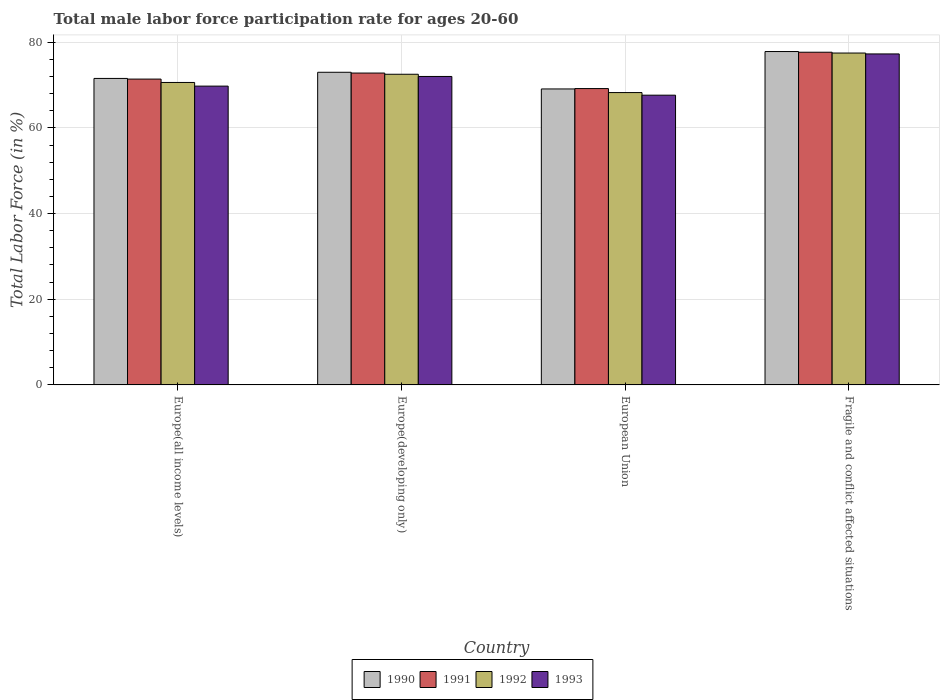How many different coloured bars are there?
Your answer should be compact. 4. Are the number of bars on each tick of the X-axis equal?
Your response must be concise. Yes. How many bars are there on the 2nd tick from the left?
Offer a very short reply. 4. What is the label of the 2nd group of bars from the left?
Provide a succinct answer. Europe(developing only). In how many cases, is the number of bars for a given country not equal to the number of legend labels?
Keep it short and to the point. 0. What is the male labor force participation rate in 1993 in Fragile and conflict affected situations?
Ensure brevity in your answer.  77.28. Across all countries, what is the maximum male labor force participation rate in 1991?
Your answer should be very brief. 77.68. Across all countries, what is the minimum male labor force participation rate in 1992?
Offer a very short reply. 68.26. In which country was the male labor force participation rate in 1990 maximum?
Your answer should be very brief. Fragile and conflict affected situations. In which country was the male labor force participation rate in 1991 minimum?
Make the answer very short. European Union. What is the total male labor force participation rate in 1990 in the graph?
Ensure brevity in your answer.  291.5. What is the difference between the male labor force participation rate in 1992 in Europe(developing only) and that in European Union?
Your answer should be compact. 4.28. What is the difference between the male labor force participation rate in 1991 in European Union and the male labor force participation rate in 1992 in Europe(all income levels)?
Give a very brief answer. -1.43. What is the average male labor force participation rate in 1991 per country?
Offer a terse response. 72.77. What is the difference between the male labor force participation rate of/in 1991 and male labor force participation rate of/in 1993 in Fragile and conflict affected situations?
Provide a succinct answer. 0.4. What is the ratio of the male labor force participation rate in 1990 in Europe(all income levels) to that in European Union?
Ensure brevity in your answer.  1.04. Is the male labor force participation rate in 1992 in Europe(all income levels) less than that in Fragile and conflict affected situations?
Make the answer very short. Yes. Is the difference between the male labor force participation rate in 1991 in Europe(developing only) and European Union greater than the difference between the male labor force participation rate in 1993 in Europe(developing only) and European Union?
Your answer should be very brief. No. What is the difference between the highest and the second highest male labor force participation rate in 1991?
Offer a very short reply. -4.86. What is the difference between the highest and the lowest male labor force participation rate in 1993?
Offer a terse response. 9.63. In how many countries, is the male labor force participation rate in 1990 greater than the average male labor force participation rate in 1990 taken over all countries?
Offer a very short reply. 2. Is the sum of the male labor force participation rate in 1992 in Europe(developing only) and European Union greater than the maximum male labor force participation rate in 1990 across all countries?
Your answer should be compact. Yes. Is it the case that in every country, the sum of the male labor force participation rate in 1991 and male labor force participation rate in 1993 is greater than the sum of male labor force participation rate in 1992 and male labor force participation rate in 1990?
Provide a short and direct response. No. What does the 1st bar from the right in Fragile and conflict affected situations represents?
Your answer should be very brief. 1993. What is the difference between two consecutive major ticks on the Y-axis?
Make the answer very short. 20. Does the graph contain grids?
Make the answer very short. Yes. Where does the legend appear in the graph?
Make the answer very short. Bottom center. How many legend labels are there?
Provide a succinct answer. 4. How are the legend labels stacked?
Make the answer very short. Horizontal. What is the title of the graph?
Ensure brevity in your answer.  Total male labor force participation rate for ages 20-60. Does "1988" appear as one of the legend labels in the graph?
Provide a succinct answer. No. What is the label or title of the Y-axis?
Provide a short and direct response. Total Labor Force (in %). What is the Total Labor Force (in %) in 1990 in Europe(all income levels)?
Your answer should be compact. 71.56. What is the Total Labor Force (in %) in 1991 in Europe(all income levels)?
Your answer should be very brief. 71.41. What is the Total Labor Force (in %) in 1992 in Europe(all income levels)?
Provide a short and direct response. 70.62. What is the Total Labor Force (in %) of 1993 in Europe(all income levels)?
Offer a terse response. 69.76. What is the Total Labor Force (in %) of 1990 in Europe(developing only)?
Provide a short and direct response. 73. What is the Total Labor Force (in %) in 1991 in Europe(developing only)?
Give a very brief answer. 72.82. What is the Total Labor Force (in %) of 1992 in Europe(developing only)?
Provide a short and direct response. 72.53. What is the Total Labor Force (in %) in 1993 in Europe(developing only)?
Your response must be concise. 72.02. What is the Total Labor Force (in %) of 1990 in European Union?
Your answer should be compact. 69.1. What is the Total Labor Force (in %) of 1991 in European Union?
Your answer should be compact. 69.19. What is the Total Labor Force (in %) of 1992 in European Union?
Your answer should be very brief. 68.26. What is the Total Labor Force (in %) in 1993 in European Union?
Your answer should be compact. 67.65. What is the Total Labor Force (in %) of 1990 in Fragile and conflict affected situations?
Ensure brevity in your answer.  77.84. What is the Total Labor Force (in %) in 1991 in Fragile and conflict affected situations?
Make the answer very short. 77.68. What is the Total Labor Force (in %) of 1992 in Fragile and conflict affected situations?
Provide a short and direct response. 77.49. What is the Total Labor Force (in %) in 1993 in Fragile and conflict affected situations?
Offer a very short reply. 77.28. Across all countries, what is the maximum Total Labor Force (in %) of 1990?
Your answer should be compact. 77.84. Across all countries, what is the maximum Total Labor Force (in %) of 1991?
Offer a very short reply. 77.68. Across all countries, what is the maximum Total Labor Force (in %) of 1992?
Provide a succinct answer. 77.49. Across all countries, what is the maximum Total Labor Force (in %) in 1993?
Provide a succinct answer. 77.28. Across all countries, what is the minimum Total Labor Force (in %) of 1990?
Keep it short and to the point. 69.1. Across all countries, what is the minimum Total Labor Force (in %) in 1991?
Offer a very short reply. 69.19. Across all countries, what is the minimum Total Labor Force (in %) of 1992?
Make the answer very short. 68.26. Across all countries, what is the minimum Total Labor Force (in %) in 1993?
Your answer should be very brief. 67.65. What is the total Total Labor Force (in %) in 1990 in the graph?
Offer a very short reply. 291.5. What is the total Total Labor Force (in %) in 1991 in the graph?
Your answer should be compact. 291.1. What is the total Total Labor Force (in %) of 1992 in the graph?
Provide a short and direct response. 288.91. What is the total Total Labor Force (in %) of 1993 in the graph?
Provide a succinct answer. 286.72. What is the difference between the Total Labor Force (in %) of 1990 in Europe(all income levels) and that in Europe(developing only)?
Give a very brief answer. -1.44. What is the difference between the Total Labor Force (in %) of 1991 in Europe(all income levels) and that in Europe(developing only)?
Your response must be concise. -1.41. What is the difference between the Total Labor Force (in %) in 1992 in Europe(all income levels) and that in Europe(developing only)?
Offer a very short reply. -1.91. What is the difference between the Total Labor Force (in %) in 1993 in Europe(all income levels) and that in Europe(developing only)?
Your answer should be very brief. -2.26. What is the difference between the Total Labor Force (in %) in 1990 in Europe(all income levels) and that in European Union?
Make the answer very short. 2.46. What is the difference between the Total Labor Force (in %) in 1991 in Europe(all income levels) and that in European Union?
Make the answer very short. 2.22. What is the difference between the Total Labor Force (in %) in 1992 in Europe(all income levels) and that in European Union?
Keep it short and to the point. 2.36. What is the difference between the Total Labor Force (in %) in 1993 in Europe(all income levels) and that in European Union?
Offer a terse response. 2.11. What is the difference between the Total Labor Force (in %) of 1990 in Europe(all income levels) and that in Fragile and conflict affected situations?
Make the answer very short. -6.28. What is the difference between the Total Labor Force (in %) in 1991 in Europe(all income levels) and that in Fragile and conflict affected situations?
Provide a short and direct response. -6.27. What is the difference between the Total Labor Force (in %) in 1992 in Europe(all income levels) and that in Fragile and conflict affected situations?
Your answer should be compact. -6.87. What is the difference between the Total Labor Force (in %) of 1993 in Europe(all income levels) and that in Fragile and conflict affected situations?
Provide a short and direct response. -7.52. What is the difference between the Total Labor Force (in %) in 1990 in Europe(developing only) and that in European Union?
Provide a short and direct response. 3.9. What is the difference between the Total Labor Force (in %) in 1991 in Europe(developing only) and that in European Union?
Make the answer very short. 3.62. What is the difference between the Total Labor Force (in %) of 1992 in Europe(developing only) and that in European Union?
Make the answer very short. 4.28. What is the difference between the Total Labor Force (in %) in 1993 in Europe(developing only) and that in European Union?
Make the answer very short. 4.37. What is the difference between the Total Labor Force (in %) in 1990 in Europe(developing only) and that in Fragile and conflict affected situations?
Ensure brevity in your answer.  -4.84. What is the difference between the Total Labor Force (in %) of 1991 in Europe(developing only) and that in Fragile and conflict affected situations?
Ensure brevity in your answer.  -4.86. What is the difference between the Total Labor Force (in %) of 1992 in Europe(developing only) and that in Fragile and conflict affected situations?
Provide a succinct answer. -4.96. What is the difference between the Total Labor Force (in %) of 1993 in Europe(developing only) and that in Fragile and conflict affected situations?
Your response must be concise. -5.26. What is the difference between the Total Labor Force (in %) of 1990 in European Union and that in Fragile and conflict affected situations?
Provide a succinct answer. -8.73. What is the difference between the Total Labor Force (in %) in 1991 in European Union and that in Fragile and conflict affected situations?
Your response must be concise. -8.49. What is the difference between the Total Labor Force (in %) of 1992 in European Union and that in Fragile and conflict affected situations?
Ensure brevity in your answer.  -9.23. What is the difference between the Total Labor Force (in %) of 1993 in European Union and that in Fragile and conflict affected situations?
Your response must be concise. -9.63. What is the difference between the Total Labor Force (in %) in 1990 in Europe(all income levels) and the Total Labor Force (in %) in 1991 in Europe(developing only)?
Ensure brevity in your answer.  -1.26. What is the difference between the Total Labor Force (in %) in 1990 in Europe(all income levels) and the Total Labor Force (in %) in 1992 in Europe(developing only)?
Your response must be concise. -0.97. What is the difference between the Total Labor Force (in %) in 1990 in Europe(all income levels) and the Total Labor Force (in %) in 1993 in Europe(developing only)?
Give a very brief answer. -0.46. What is the difference between the Total Labor Force (in %) in 1991 in Europe(all income levels) and the Total Labor Force (in %) in 1992 in Europe(developing only)?
Your answer should be compact. -1.12. What is the difference between the Total Labor Force (in %) of 1991 in Europe(all income levels) and the Total Labor Force (in %) of 1993 in Europe(developing only)?
Your response must be concise. -0.61. What is the difference between the Total Labor Force (in %) of 1992 in Europe(all income levels) and the Total Labor Force (in %) of 1993 in Europe(developing only)?
Your answer should be compact. -1.4. What is the difference between the Total Labor Force (in %) in 1990 in Europe(all income levels) and the Total Labor Force (in %) in 1991 in European Union?
Provide a succinct answer. 2.37. What is the difference between the Total Labor Force (in %) of 1990 in Europe(all income levels) and the Total Labor Force (in %) of 1992 in European Union?
Provide a succinct answer. 3.3. What is the difference between the Total Labor Force (in %) of 1990 in Europe(all income levels) and the Total Labor Force (in %) of 1993 in European Union?
Make the answer very short. 3.91. What is the difference between the Total Labor Force (in %) in 1991 in Europe(all income levels) and the Total Labor Force (in %) in 1992 in European Union?
Offer a terse response. 3.15. What is the difference between the Total Labor Force (in %) of 1991 in Europe(all income levels) and the Total Labor Force (in %) of 1993 in European Union?
Offer a terse response. 3.76. What is the difference between the Total Labor Force (in %) of 1992 in Europe(all income levels) and the Total Labor Force (in %) of 1993 in European Union?
Keep it short and to the point. 2.97. What is the difference between the Total Labor Force (in %) in 1990 in Europe(all income levels) and the Total Labor Force (in %) in 1991 in Fragile and conflict affected situations?
Give a very brief answer. -6.12. What is the difference between the Total Labor Force (in %) of 1990 in Europe(all income levels) and the Total Labor Force (in %) of 1992 in Fragile and conflict affected situations?
Offer a terse response. -5.93. What is the difference between the Total Labor Force (in %) in 1990 in Europe(all income levels) and the Total Labor Force (in %) in 1993 in Fragile and conflict affected situations?
Your answer should be compact. -5.72. What is the difference between the Total Labor Force (in %) of 1991 in Europe(all income levels) and the Total Labor Force (in %) of 1992 in Fragile and conflict affected situations?
Provide a short and direct response. -6.08. What is the difference between the Total Labor Force (in %) in 1991 in Europe(all income levels) and the Total Labor Force (in %) in 1993 in Fragile and conflict affected situations?
Your response must be concise. -5.87. What is the difference between the Total Labor Force (in %) of 1992 in Europe(all income levels) and the Total Labor Force (in %) of 1993 in Fragile and conflict affected situations?
Offer a terse response. -6.66. What is the difference between the Total Labor Force (in %) of 1990 in Europe(developing only) and the Total Labor Force (in %) of 1991 in European Union?
Your answer should be very brief. 3.81. What is the difference between the Total Labor Force (in %) of 1990 in Europe(developing only) and the Total Labor Force (in %) of 1992 in European Union?
Your answer should be very brief. 4.74. What is the difference between the Total Labor Force (in %) in 1990 in Europe(developing only) and the Total Labor Force (in %) in 1993 in European Union?
Make the answer very short. 5.35. What is the difference between the Total Labor Force (in %) of 1991 in Europe(developing only) and the Total Labor Force (in %) of 1992 in European Union?
Provide a succinct answer. 4.56. What is the difference between the Total Labor Force (in %) in 1991 in Europe(developing only) and the Total Labor Force (in %) in 1993 in European Union?
Give a very brief answer. 5.17. What is the difference between the Total Labor Force (in %) in 1992 in Europe(developing only) and the Total Labor Force (in %) in 1993 in European Union?
Offer a terse response. 4.88. What is the difference between the Total Labor Force (in %) in 1990 in Europe(developing only) and the Total Labor Force (in %) in 1991 in Fragile and conflict affected situations?
Provide a succinct answer. -4.68. What is the difference between the Total Labor Force (in %) in 1990 in Europe(developing only) and the Total Labor Force (in %) in 1992 in Fragile and conflict affected situations?
Offer a terse response. -4.49. What is the difference between the Total Labor Force (in %) in 1990 in Europe(developing only) and the Total Labor Force (in %) in 1993 in Fragile and conflict affected situations?
Provide a succinct answer. -4.28. What is the difference between the Total Labor Force (in %) in 1991 in Europe(developing only) and the Total Labor Force (in %) in 1992 in Fragile and conflict affected situations?
Offer a terse response. -4.68. What is the difference between the Total Labor Force (in %) in 1991 in Europe(developing only) and the Total Labor Force (in %) in 1993 in Fragile and conflict affected situations?
Your answer should be compact. -4.47. What is the difference between the Total Labor Force (in %) of 1992 in Europe(developing only) and the Total Labor Force (in %) of 1993 in Fragile and conflict affected situations?
Make the answer very short. -4.75. What is the difference between the Total Labor Force (in %) in 1990 in European Union and the Total Labor Force (in %) in 1991 in Fragile and conflict affected situations?
Your answer should be compact. -8.58. What is the difference between the Total Labor Force (in %) in 1990 in European Union and the Total Labor Force (in %) in 1992 in Fragile and conflict affected situations?
Your response must be concise. -8.39. What is the difference between the Total Labor Force (in %) in 1990 in European Union and the Total Labor Force (in %) in 1993 in Fragile and conflict affected situations?
Provide a succinct answer. -8.18. What is the difference between the Total Labor Force (in %) in 1991 in European Union and the Total Labor Force (in %) in 1992 in Fragile and conflict affected situations?
Your response must be concise. -8.3. What is the difference between the Total Labor Force (in %) in 1991 in European Union and the Total Labor Force (in %) in 1993 in Fragile and conflict affected situations?
Keep it short and to the point. -8.09. What is the difference between the Total Labor Force (in %) in 1992 in European Union and the Total Labor Force (in %) in 1993 in Fragile and conflict affected situations?
Give a very brief answer. -9.02. What is the average Total Labor Force (in %) in 1990 per country?
Provide a short and direct response. 72.88. What is the average Total Labor Force (in %) in 1991 per country?
Your response must be concise. 72.77. What is the average Total Labor Force (in %) of 1992 per country?
Ensure brevity in your answer.  72.23. What is the average Total Labor Force (in %) of 1993 per country?
Offer a very short reply. 71.68. What is the difference between the Total Labor Force (in %) of 1990 and Total Labor Force (in %) of 1991 in Europe(all income levels)?
Ensure brevity in your answer.  0.15. What is the difference between the Total Labor Force (in %) of 1990 and Total Labor Force (in %) of 1992 in Europe(all income levels)?
Your answer should be compact. 0.94. What is the difference between the Total Labor Force (in %) of 1990 and Total Labor Force (in %) of 1993 in Europe(all income levels)?
Give a very brief answer. 1.8. What is the difference between the Total Labor Force (in %) in 1991 and Total Labor Force (in %) in 1992 in Europe(all income levels)?
Provide a short and direct response. 0.79. What is the difference between the Total Labor Force (in %) in 1991 and Total Labor Force (in %) in 1993 in Europe(all income levels)?
Provide a short and direct response. 1.64. What is the difference between the Total Labor Force (in %) in 1992 and Total Labor Force (in %) in 1993 in Europe(all income levels)?
Offer a very short reply. 0.86. What is the difference between the Total Labor Force (in %) in 1990 and Total Labor Force (in %) in 1991 in Europe(developing only)?
Provide a succinct answer. 0.18. What is the difference between the Total Labor Force (in %) in 1990 and Total Labor Force (in %) in 1992 in Europe(developing only)?
Your response must be concise. 0.47. What is the difference between the Total Labor Force (in %) in 1990 and Total Labor Force (in %) in 1993 in Europe(developing only)?
Your response must be concise. 0.98. What is the difference between the Total Labor Force (in %) in 1991 and Total Labor Force (in %) in 1992 in Europe(developing only)?
Ensure brevity in your answer.  0.28. What is the difference between the Total Labor Force (in %) in 1991 and Total Labor Force (in %) in 1993 in Europe(developing only)?
Keep it short and to the point. 0.79. What is the difference between the Total Labor Force (in %) in 1992 and Total Labor Force (in %) in 1993 in Europe(developing only)?
Offer a terse response. 0.51. What is the difference between the Total Labor Force (in %) of 1990 and Total Labor Force (in %) of 1991 in European Union?
Provide a short and direct response. -0.09. What is the difference between the Total Labor Force (in %) of 1990 and Total Labor Force (in %) of 1992 in European Union?
Offer a very short reply. 0.85. What is the difference between the Total Labor Force (in %) of 1990 and Total Labor Force (in %) of 1993 in European Union?
Provide a succinct answer. 1.45. What is the difference between the Total Labor Force (in %) of 1991 and Total Labor Force (in %) of 1992 in European Union?
Your response must be concise. 0.93. What is the difference between the Total Labor Force (in %) in 1991 and Total Labor Force (in %) in 1993 in European Union?
Your response must be concise. 1.54. What is the difference between the Total Labor Force (in %) in 1992 and Total Labor Force (in %) in 1993 in European Union?
Offer a terse response. 0.61. What is the difference between the Total Labor Force (in %) in 1990 and Total Labor Force (in %) in 1991 in Fragile and conflict affected situations?
Offer a terse response. 0.16. What is the difference between the Total Labor Force (in %) of 1990 and Total Labor Force (in %) of 1992 in Fragile and conflict affected situations?
Your response must be concise. 0.35. What is the difference between the Total Labor Force (in %) in 1990 and Total Labor Force (in %) in 1993 in Fragile and conflict affected situations?
Your answer should be very brief. 0.56. What is the difference between the Total Labor Force (in %) in 1991 and Total Labor Force (in %) in 1992 in Fragile and conflict affected situations?
Keep it short and to the point. 0.19. What is the difference between the Total Labor Force (in %) of 1991 and Total Labor Force (in %) of 1993 in Fragile and conflict affected situations?
Give a very brief answer. 0.4. What is the difference between the Total Labor Force (in %) in 1992 and Total Labor Force (in %) in 1993 in Fragile and conflict affected situations?
Your answer should be compact. 0.21. What is the ratio of the Total Labor Force (in %) of 1990 in Europe(all income levels) to that in Europe(developing only)?
Offer a very short reply. 0.98. What is the ratio of the Total Labor Force (in %) of 1991 in Europe(all income levels) to that in Europe(developing only)?
Provide a short and direct response. 0.98. What is the ratio of the Total Labor Force (in %) of 1992 in Europe(all income levels) to that in Europe(developing only)?
Offer a terse response. 0.97. What is the ratio of the Total Labor Force (in %) of 1993 in Europe(all income levels) to that in Europe(developing only)?
Provide a succinct answer. 0.97. What is the ratio of the Total Labor Force (in %) of 1990 in Europe(all income levels) to that in European Union?
Make the answer very short. 1.04. What is the ratio of the Total Labor Force (in %) in 1991 in Europe(all income levels) to that in European Union?
Keep it short and to the point. 1.03. What is the ratio of the Total Labor Force (in %) in 1992 in Europe(all income levels) to that in European Union?
Offer a very short reply. 1.03. What is the ratio of the Total Labor Force (in %) in 1993 in Europe(all income levels) to that in European Union?
Give a very brief answer. 1.03. What is the ratio of the Total Labor Force (in %) of 1990 in Europe(all income levels) to that in Fragile and conflict affected situations?
Keep it short and to the point. 0.92. What is the ratio of the Total Labor Force (in %) in 1991 in Europe(all income levels) to that in Fragile and conflict affected situations?
Your response must be concise. 0.92. What is the ratio of the Total Labor Force (in %) in 1992 in Europe(all income levels) to that in Fragile and conflict affected situations?
Keep it short and to the point. 0.91. What is the ratio of the Total Labor Force (in %) of 1993 in Europe(all income levels) to that in Fragile and conflict affected situations?
Provide a short and direct response. 0.9. What is the ratio of the Total Labor Force (in %) of 1990 in Europe(developing only) to that in European Union?
Ensure brevity in your answer.  1.06. What is the ratio of the Total Labor Force (in %) of 1991 in Europe(developing only) to that in European Union?
Offer a very short reply. 1.05. What is the ratio of the Total Labor Force (in %) of 1992 in Europe(developing only) to that in European Union?
Give a very brief answer. 1.06. What is the ratio of the Total Labor Force (in %) of 1993 in Europe(developing only) to that in European Union?
Ensure brevity in your answer.  1.06. What is the ratio of the Total Labor Force (in %) of 1990 in Europe(developing only) to that in Fragile and conflict affected situations?
Make the answer very short. 0.94. What is the ratio of the Total Labor Force (in %) of 1991 in Europe(developing only) to that in Fragile and conflict affected situations?
Make the answer very short. 0.94. What is the ratio of the Total Labor Force (in %) of 1992 in Europe(developing only) to that in Fragile and conflict affected situations?
Give a very brief answer. 0.94. What is the ratio of the Total Labor Force (in %) of 1993 in Europe(developing only) to that in Fragile and conflict affected situations?
Give a very brief answer. 0.93. What is the ratio of the Total Labor Force (in %) in 1990 in European Union to that in Fragile and conflict affected situations?
Ensure brevity in your answer.  0.89. What is the ratio of the Total Labor Force (in %) of 1991 in European Union to that in Fragile and conflict affected situations?
Provide a short and direct response. 0.89. What is the ratio of the Total Labor Force (in %) of 1992 in European Union to that in Fragile and conflict affected situations?
Ensure brevity in your answer.  0.88. What is the ratio of the Total Labor Force (in %) of 1993 in European Union to that in Fragile and conflict affected situations?
Ensure brevity in your answer.  0.88. What is the difference between the highest and the second highest Total Labor Force (in %) of 1990?
Your response must be concise. 4.84. What is the difference between the highest and the second highest Total Labor Force (in %) of 1991?
Offer a terse response. 4.86. What is the difference between the highest and the second highest Total Labor Force (in %) of 1992?
Give a very brief answer. 4.96. What is the difference between the highest and the second highest Total Labor Force (in %) in 1993?
Ensure brevity in your answer.  5.26. What is the difference between the highest and the lowest Total Labor Force (in %) in 1990?
Your response must be concise. 8.73. What is the difference between the highest and the lowest Total Labor Force (in %) in 1991?
Your answer should be compact. 8.49. What is the difference between the highest and the lowest Total Labor Force (in %) of 1992?
Provide a short and direct response. 9.23. What is the difference between the highest and the lowest Total Labor Force (in %) in 1993?
Offer a very short reply. 9.63. 